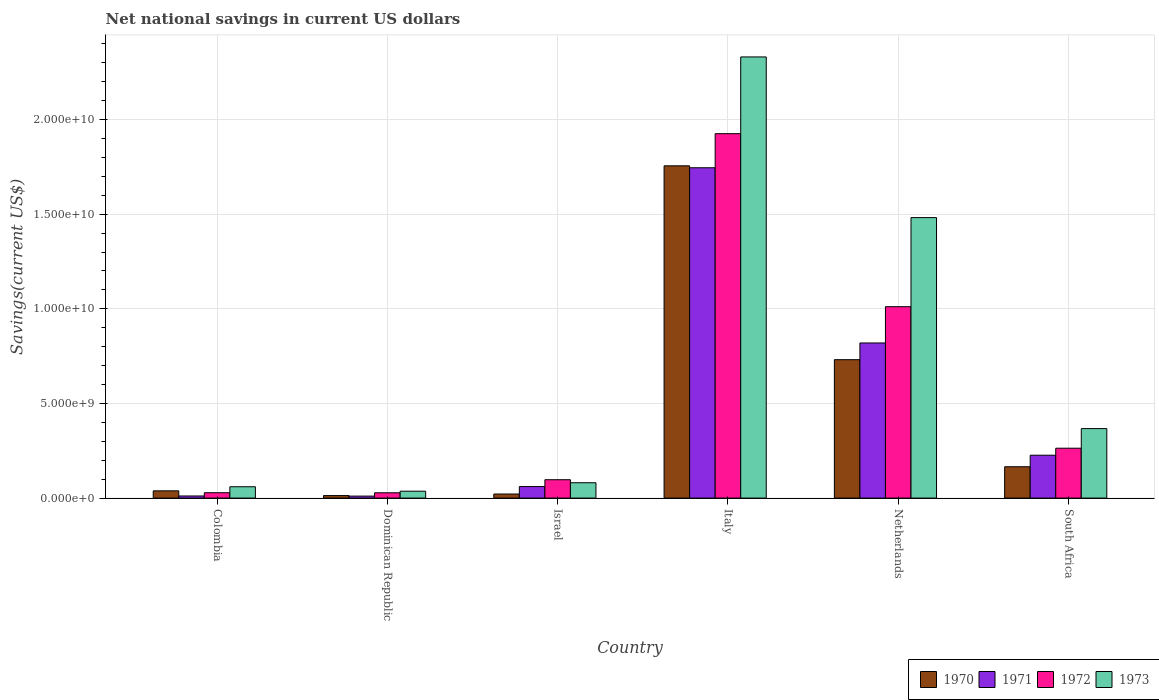How many different coloured bars are there?
Your answer should be very brief. 4. Are the number of bars per tick equal to the number of legend labels?
Your answer should be compact. Yes. How many bars are there on the 4th tick from the left?
Provide a succinct answer. 4. What is the net national savings in 1972 in Italy?
Give a very brief answer. 1.93e+1. Across all countries, what is the maximum net national savings in 1970?
Ensure brevity in your answer.  1.76e+1. Across all countries, what is the minimum net national savings in 1971?
Offer a terse response. 1.05e+08. In which country was the net national savings in 1971 minimum?
Offer a very short reply. Dominican Republic. What is the total net national savings in 1972 in the graph?
Ensure brevity in your answer.  3.35e+1. What is the difference between the net national savings in 1971 in Dominican Republic and that in Italy?
Offer a terse response. -1.73e+1. What is the difference between the net national savings in 1973 in South Africa and the net national savings in 1972 in Israel?
Offer a very short reply. 2.70e+09. What is the average net national savings in 1970 per country?
Offer a terse response. 4.54e+09. What is the difference between the net national savings of/in 1970 and net national savings of/in 1972 in Netherlands?
Your response must be concise. -2.80e+09. In how many countries, is the net national savings in 1972 greater than 10000000000 US$?
Keep it short and to the point. 2. What is the ratio of the net national savings in 1972 in Dominican Republic to that in Netherlands?
Offer a very short reply. 0.03. Is the net national savings in 1971 in Israel less than that in Italy?
Your response must be concise. Yes. Is the difference between the net national savings in 1970 in Colombia and Israel greater than the difference between the net national savings in 1972 in Colombia and Israel?
Provide a short and direct response. Yes. What is the difference between the highest and the second highest net national savings in 1970?
Offer a very short reply. 1.02e+1. What is the difference between the highest and the lowest net national savings in 1971?
Give a very brief answer. 1.73e+1. In how many countries, is the net national savings in 1972 greater than the average net national savings in 1972 taken over all countries?
Ensure brevity in your answer.  2. How many bars are there?
Ensure brevity in your answer.  24. What is the difference between two consecutive major ticks on the Y-axis?
Your response must be concise. 5.00e+09. Does the graph contain any zero values?
Your response must be concise. No. Does the graph contain grids?
Ensure brevity in your answer.  Yes. How many legend labels are there?
Offer a terse response. 4. What is the title of the graph?
Ensure brevity in your answer.  Net national savings in current US dollars. What is the label or title of the X-axis?
Your answer should be compact. Country. What is the label or title of the Y-axis?
Your answer should be very brief. Savings(current US$). What is the Savings(current US$) of 1970 in Colombia?
Offer a very short reply. 3.83e+08. What is the Savings(current US$) of 1971 in Colombia?
Provide a short and direct response. 1.11e+08. What is the Savings(current US$) of 1972 in Colombia?
Provide a short and direct response. 2.84e+08. What is the Savings(current US$) in 1973 in Colombia?
Keep it short and to the point. 5.98e+08. What is the Savings(current US$) in 1970 in Dominican Republic?
Your response must be concise. 1.33e+08. What is the Savings(current US$) of 1971 in Dominican Republic?
Give a very brief answer. 1.05e+08. What is the Savings(current US$) of 1972 in Dominican Republic?
Ensure brevity in your answer.  2.80e+08. What is the Savings(current US$) of 1973 in Dominican Republic?
Offer a very short reply. 3.65e+08. What is the Savings(current US$) in 1970 in Israel?
Provide a short and direct response. 2.15e+08. What is the Savings(current US$) in 1971 in Israel?
Provide a succinct answer. 6.09e+08. What is the Savings(current US$) of 1972 in Israel?
Your answer should be compact. 9.71e+08. What is the Savings(current US$) of 1973 in Israel?
Keep it short and to the point. 8.11e+08. What is the Savings(current US$) in 1970 in Italy?
Give a very brief answer. 1.76e+1. What is the Savings(current US$) in 1971 in Italy?
Your answer should be compact. 1.75e+1. What is the Savings(current US$) of 1972 in Italy?
Offer a terse response. 1.93e+1. What is the Savings(current US$) in 1973 in Italy?
Give a very brief answer. 2.33e+1. What is the Savings(current US$) in 1970 in Netherlands?
Your answer should be very brief. 7.31e+09. What is the Savings(current US$) in 1971 in Netherlands?
Give a very brief answer. 8.20e+09. What is the Savings(current US$) in 1972 in Netherlands?
Your response must be concise. 1.01e+1. What is the Savings(current US$) in 1973 in Netherlands?
Ensure brevity in your answer.  1.48e+1. What is the Savings(current US$) in 1970 in South Africa?
Your response must be concise. 1.66e+09. What is the Savings(current US$) of 1971 in South Africa?
Keep it short and to the point. 2.27e+09. What is the Savings(current US$) of 1972 in South Africa?
Provide a succinct answer. 2.64e+09. What is the Savings(current US$) of 1973 in South Africa?
Provide a short and direct response. 3.67e+09. Across all countries, what is the maximum Savings(current US$) of 1970?
Make the answer very short. 1.76e+1. Across all countries, what is the maximum Savings(current US$) of 1971?
Provide a short and direct response. 1.75e+1. Across all countries, what is the maximum Savings(current US$) of 1972?
Offer a very short reply. 1.93e+1. Across all countries, what is the maximum Savings(current US$) of 1973?
Keep it short and to the point. 2.33e+1. Across all countries, what is the minimum Savings(current US$) of 1970?
Offer a very short reply. 1.33e+08. Across all countries, what is the minimum Savings(current US$) of 1971?
Make the answer very short. 1.05e+08. Across all countries, what is the minimum Savings(current US$) in 1972?
Offer a very short reply. 2.80e+08. Across all countries, what is the minimum Savings(current US$) of 1973?
Your answer should be very brief. 3.65e+08. What is the total Savings(current US$) in 1970 in the graph?
Your answer should be very brief. 2.73e+1. What is the total Savings(current US$) in 1971 in the graph?
Your response must be concise. 2.87e+1. What is the total Savings(current US$) in 1972 in the graph?
Offer a very short reply. 3.35e+1. What is the total Savings(current US$) of 1973 in the graph?
Provide a succinct answer. 4.36e+1. What is the difference between the Savings(current US$) in 1970 in Colombia and that in Dominican Republic?
Offer a very short reply. 2.50e+08. What is the difference between the Savings(current US$) of 1971 in Colombia and that in Dominican Republic?
Keep it short and to the point. 6.03e+06. What is the difference between the Savings(current US$) of 1972 in Colombia and that in Dominican Republic?
Offer a very short reply. 3.48e+06. What is the difference between the Savings(current US$) in 1973 in Colombia and that in Dominican Republic?
Keep it short and to the point. 2.34e+08. What is the difference between the Savings(current US$) of 1970 in Colombia and that in Israel?
Provide a short and direct response. 1.68e+08. What is the difference between the Savings(current US$) in 1971 in Colombia and that in Israel?
Provide a short and direct response. -4.97e+08. What is the difference between the Savings(current US$) of 1972 in Colombia and that in Israel?
Offer a very short reply. -6.87e+08. What is the difference between the Savings(current US$) of 1973 in Colombia and that in Israel?
Offer a very short reply. -2.12e+08. What is the difference between the Savings(current US$) in 1970 in Colombia and that in Italy?
Offer a terse response. -1.72e+1. What is the difference between the Savings(current US$) in 1971 in Colombia and that in Italy?
Offer a very short reply. -1.73e+1. What is the difference between the Savings(current US$) of 1972 in Colombia and that in Italy?
Give a very brief answer. -1.90e+1. What is the difference between the Savings(current US$) in 1973 in Colombia and that in Italy?
Ensure brevity in your answer.  -2.27e+1. What is the difference between the Savings(current US$) of 1970 in Colombia and that in Netherlands?
Your answer should be compact. -6.93e+09. What is the difference between the Savings(current US$) in 1971 in Colombia and that in Netherlands?
Make the answer very short. -8.08e+09. What is the difference between the Savings(current US$) in 1972 in Colombia and that in Netherlands?
Offer a terse response. -9.83e+09. What is the difference between the Savings(current US$) of 1973 in Colombia and that in Netherlands?
Ensure brevity in your answer.  -1.42e+1. What is the difference between the Savings(current US$) in 1970 in Colombia and that in South Africa?
Give a very brief answer. -1.27e+09. What is the difference between the Savings(current US$) in 1971 in Colombia and that in South Africa?
Ensure brevity in your answer.  -2.15e+09. What is the difference between the Savings(current US$) in 1972 in Colombia and that in South Africa?
Give a very brief answer. -2.35e+09. What is the difference between the Savings(current US$) in 1973 in Colombia and that in South Africa?
Give a very brief answer. -3.07e+09. What is the difference between the Savings(current US$) in 1970 in Dominican Republic and that in Israel?
Ensure brevity in your answer.  -8.19e+07. What is the difference between the Savings(current US$) in 1971 in Dominican Republic and that in Israel?
Offer a very short reply. -5.03e+08. What is the difference between the Savings(current US$) in 1972 in Dominican Republic and that in Israel?
Your answer should be very brief. -6.90e+08. What is the difference between the Savings(current US$) in 1973 in Dominican Republic and that in Israel?
Provide a short and direct response. -4.46e+08. What is the difference between the Savings(current US$) of 1970 in Dominican Republic and that in Italy?
Provide a short and direct response. -1.74e+1. What is the difference between the Savings(current US$) of 1971 in Dominican Republic and that in Italy?
Provide a succinct answer. -1.73e+1. What is the difference between the Savings(current US$) in 1972 in Dominican Republic and that in Italy?
Provide a succinct answer. -1.90e+1. What is the difference between the Savings(current US$) of 1973 in Dominican Republic and that in Italy?
Offer a very short reply. -2.29e+1. What is the difference between the Savings(current US$) in 1970 in Dominican Republic and that in Netherlands?
Offer a very short reply. -7.18e+09. What is the difference between the Savings(current US$) of 1971 in Dominican Republic and that in Netherlands?
Your answer should be compact. -8.09e+09. What is the difference between the Savings(current US$) in 1972 in Dominican Republic and that in Netherlands?
Offer a terse response. -9.83e+09. What is the difference between the Savings(current US$) of 1973 in Dominican Republic and that in Netherlands?
Ensure brevity in your answer.  -1.45e+1. What is the difference between the Savings(current US$) of 1970 in Dominican Republic and that in South Africa?
Keep it short and to the point. -1.52e+09. What is the difference between the Savings(current US$) in 1971 in Dominican Republic and that in South Africa?
Ensure brevity in your answer.  -2.16e+09. What is the difference between the Savings(current US$) of 1972 in Dominican Republic and that in South Africa?
Make the answer very short. -2.35e+09. What is the difference between the Savings(current US$) of 1973 in Dominican Republic and that in South Africa?
Give a very brief answer. -3.31e+09. What is the difference between the Savings(current US$) of 1970 in Israel and that in Italy?
Your answer should be very brief. -1.73e+1. What is the difference between the Savings(current US$) of 1971 in Israel and that in Italy?
Keep it short and to the point. -1.68e+1. What is the difference between the Savings(current US$) of 1972 in Israel and that in Italy?
Keep it short and to the point. -1.83e+1. What is the difference between the Savings(current US$) of 1973 in Israel and that in Italy?
Your answer should be compact. -2.25e+1. What is the difference between the Savings(current US$) of 1970 in Israel and that in Netherlands?
Give a very brief answer. -7.10e+09. What is the difference between the Savings(current US$) in 1971 in Israel and that in Netherlands?
Ensure brevity in your answer.  -7.59e+09. What is the difference between the Savings(current US$) of 1972 in Israel and that in Netherlands?
Make the answer very short. -9.14e+09. What is the difference between the Savings(current US$) of 1973 in Israel and that in Netherlands?
Your response must be concise. -1.40e+1. What is the difference between the Savings(current US$) in 1970 in Israel and that in South Africa?
Your response must be concise. -1.44e+09. What is the difference between the Savings(current US$) in 1971 in Israel and that in South Africa?
Keep it short and to the point. -1.66e+09. What is the difference between the Savings(current US$) of 1972 in Israel and that in South Africa?
Keep it short and to the point. -1.66e+09. What is the difference between the Savings(current US$) of 1973 in Israel and that in South Africa?
Ensure brevity in your answer.  -2.86e+09. What is the difference between the Savings(current US$) of 1970 in Italy and that in Netherlands?
Offer a very short reply. 1.02e+1. What is the difference between the Savings(current US$) in 1971 in Italy and that in Netherlands?
Offer a very short reply. 9.26e+09. What is the difference between the Savings(current US$) in 1972 in Italy and that in Netherlands?
Offer a very short reply. 9.14e+09. What is the difference between the Savings(current US$) in 1973 in Italy and that in Netherlands?
Offer a very short reply. 8.49e+09. What is the difference between the Savings(current US$) of 1970 in Italy and that in South Africa?
Your answer should be compact. 1.59e+1. What is the difference between the Savings(current US$) in 1971 in Italy and that in South Africa?
Offer a very short reply. 1.52e+1. What is the difference between the Savings(current US$) of 1972 in Italy and that in South Africa?
Keep it short and to the point. 1.66e+1. What is the difference between the Savings(current US$) in 1973 in Italy and that in South Africa?
Ensure brevity in your answer.  1.96e+1. What is the difference between the Savings(current US$) of 1970 in Netherlands and that in South Africa?
Your answer should be very brief. 5.66e+09. What is the difference between the Savings(current US$) in 1971 in Netherlands and that in South Africa?
Offer a very short reply. 5.93e+09. What is the difference between the Savings(current US$) in 1972 in Netherlands and that in South Africa?
Your answer should be very brief. 7.48e+09. What is the difference between the Savings(current US$) of 1973 in Netherlands and that in South Africa?
Your answer should be compact. 1.11e+1. What is the difference between the Savings(current US$) of 1970 in Colombia and the Savings(current US$) of 1971 in Dominican Republic?
Your answer should be compact. 2.77e+08. What is the difference between the Savings(current US$) in 1970 in Colombia and the Savings(current US$) in 1972 in Dominican Republic?
Your answer should be very brief. 1.02e+08. What is the difference between the Savings(current US$) of 1970 in Colombia and the Savings(current US$) of 1973 in Dominican Republic?
Your answer should be very brief. 1.82e+07. What is the difference between the Savings(current US$) of 1971 in Colombia and the Savings(current US$) of 1972 in Dominican Republic?
Provide a succinct answer. -1.69e+08. What is the difference between the Savings(current US$) of 1971 in Colombia and the Savings(current US$) of 1973 in Dominican Republic?
Your answer should be very brief. -2.53e+08. What is the difference between the Savings(current US$) of 1972 in Colombia and the Savings(current US$) of 1973 in Dominican Republic?
Your answer should be very brief. -8.05e+07. What is the difference between the Savings(current US$) in 1970 in Colombia and the Savings(current US$) in 1971 in Israel?
Your response must be concise. -2.26e+08. What is the difference between the Savings(current US$) of 1970 in Colombia and the Savings(current US$) of 1972 in Israel?
Your response must be concise. -5.88e+08. What is the difference between the Savings(current US$) of 1970 in Colombia and the Savings(current US$) of 1973 in Israel?
Offer a very short reply. -4.28e+08. What is the difference between the Savings(current US$) of 1971 in Colombia and the Savings(current US$) of 1972 in Israel?
Ensure brevity in your answer.  -8.59e+08. What is the difference between the Savings(current US$) of 1971 in Colombia and the Savings(current US$) of 1973 in Israel?
Your answer should be compact. -6.99e+08. What is the difference between the Savings(current US$) in 1972 in Colombia and the Savings(current US$) in 1973 in Israel?
Provide a short and direct response. -5.27e+08. What is the difference between the Savings(current US$) of 1970 in Colombia and the Savings(current US$) of 1971 in Italy?
Your answer should be very brief. -1.71e+1. What is the difference between the Savings(current US$) of 1970 in Colombia and the Savings(current US$) of 1972 in Italy?
Offer a very short reply. -1.89e+1. What is the difference between the Savings(current US$) of 1970 in Colombia and the Savings(current US$) of 1973 in Italy?
Make the answer very short. -2.29e+1. What is the difference between the Savings(current US$) in 1971 in Colombia and the Savings(current US$) in 1972 in Italy?
Your answer should be compact. -1.91e+1. What is the difference between the Savings(current US$) in 1971 in Colombia and the Savings(current US$) in 1973 in Italy?
Your response must be concise. -2.32e+1. What is the difference between the Savings(current US$) of 1972 in Colombia and the Savings(current US$) of 1973 in Italy?
Make the answer very short. -2.30e+1. What is the difference between the Savings(current US$) of 1970 in Colombia and the Savings(current US$) of 1971 in Netherlands?
Offer a very short reply. -7.81e+09. What is the difference between the Savings(current US$) of 1970 in Colombia and the Savings(current US$) of 1972 in Netherlands?
Keep it short and to the point. -9.73e+09. What is the difference between the Savings(current US$) of 1970 in Colombia and the Savings(current US$) of 1973 in Netherlands?
Make the answer very short. -1.44e+1. What is the difference between the Savings(current US$) of 1971 in Colombia and the Savings(current US$) of 1972 in Netherlands?
Provide a succinct answer. -1.00e+1. What is the difference between the Savings(current US$) in 1971 in Colombia and the Savings(current US$) in 1973 in Netherlands?
Your answer should be very brief. -1.47e+1. What is the difference between the Savings(current US$) in 1972 in Colombia and the Savings(current US$) in 1973 in Netherlands?
Offer a terse response. -1.45e+1. What is the difference between the Savings(current US$) of 1970 in Colombia and the Savings(current US$) of 1971 in South Africa?
Provide a short and direct response. -1.88e+09. What is the difference between the Savings(current US$) in 1970 in Colombia and the Savings(current US$) in 1972 in South Africa?
Offer a terse response. -2.25e+09. What is the difference between the Savings(current US$) of 1970 in Colombia and the Savings(current US$) of 1973 in South Africa?
Ensure brevity in your answer.  -3.29e+09. What is the difference between the Savings(current US$) of 1971 in Colombia and the Savings(current US$) of 1972 in South Africa?
Provide a succinct answer. -2.52e+09. What is the difference between the Savings(current US$) in 1971 in Colombia and the Savings(current US$) in 1973 in South Africa?
Ensure brevity in your answer.  -3.56e+09. What is the difference between the Savings(current US$) in 1972 in Colombia and the Savings(current US$) in 1973 in South Africa?
Your answer should be compact. -3.39e+09. What is the difference between the Savings(current US$) of 1970 in Dominican Republic and the Savings(current US$) of 1971 in Israel?
Provide a short and direct response. -4.76e+08. What is the difference between the Savings(current US$) in 1970 in Dominican Republic and the Savings(current US$) in 1972 in Israel?
Your response must be concise. -8.38e+08. What is the difference between the Savings(current US$) in 1970 in Dominican Republic and the Savings(current US$) in 1973 in Israel?
Provide a succinct answer. -6.78e+08. What is the difference between the Savings(current US$) of 1971 in Dominican Republic and the Savings(current US$) of 1972 in Israel?
Your answer should be compact. -8.65e+08. What is the difference between the Savings(current US$) in 1971 in Dominican Republic and the Savings(current US$) in 1973 in Israel?
Your answer should be very brief. -7.05e+08. What is the difference between the Savings(current US$) in 1972 in Dominican Republic and the Savings(current US$) in 1973 in Israel?
Keep it short and to the point. -5.30e+08. What is the difference between the Savings(current US$) in 1970 in Dominican Republic and the Savings(current US$) in 1971 in Italy?
Make the answer very short. -1.73e+1. What is the difference between the Savings(current US$) of 1970 in Dominican Republic and the Savings(current US$) of 1972 in Italy?
Offer a very short reply. -1.91e+1. What is the difference between the Savings(current US$) in 1970 in Dominican Republic and the Savings(current US$) in 1973 in Italy?
Your answer should be compact. -2.32e+1. What is the difference between the Savings(current US$) of 1971 in Dominican Republic and the Savings(current US$) of 1972 in Italy?
Your answer should be very brief. -1.91e+1. What is the difference between the Savings(current US$) of 1971 in Dominican Republic and the Savings(current US$) of 1973 in Italy?
Provide a succinct answer. -2.32e+1. What is the difference between the Savings(current US$) of 1972 in Dominican Republic and the Savings(current US$) of 1973 in Italy?
Keep it short and to the point. -2.30e+1. What is the difference between the Savings(current US$) of 1970 in Dominican Republic and the Savings(current US$) of 1971 in Netherlands?
Your answer should be compact. -8.06e+09. What is the difference between the Savings(current US$) in 1970 in Dominican Republic and the Savings(current US$) in 1972 in Netherlands?
Offer a very short reply. -9.98e+09. What is the difference between the Savings(current US$) in 1970 in Dominican Republic and the Savings(current US$) in 1973 in Netherlands?
Keep it short and to the point. -1.47e+1. What is the difference between the Savings(current US$) in 1971 in Dominican Republic and the Savings(current US$) in 1972 in Netherlands?
Ensure brevity in your answer.  -1.00e+1. What is the difference between the Savings(current US$) of 1971 in Dominican Republic and the Savings(current US$) of 1973 in Netherlands?
Your response must be concise. -1.47e+1. What is the difference between the Savings(current US$) of 1972 in Dominican Republic and the Savings(current US$) of 1973 in Netherlands?
Your response must be concise. -1.45e+1. What is the difference between the Savings(current US$) in 1970 in Dominican Republic and the Savings(current US$) in 1971 in South Africa?
Your answer should be very brief. -2.13e+09. What is the difference between the Savings(current US$) of 1970 in Dominican Republic and the Savings(current US$) of 1972 in South Africa?
Offer a very short reply. -2.50e+09. What is the difference between the Savings(current US$) of 1970 in Dominican Republic and the Savings(current US$) of 1973 in South Africa?
Provide a short and direct response. -3.54e+09. What is the difference between the Savings(current US$) in 1971 in Dominican Republic and the Savings(current US$) in 1972 in South Africa?
Your answer should be compact. -2.53e+09. What is the difference between the Savings(current US$) of 1971 in Dominican Republic and the Savings(current US$) of 1973 in South Africa?
Make the answer very short. -3.57e+09. What is the difference between the Savings(current US$) of 1972 in Dominican Republic and the Savings(current US$) of 1973 in South Africa?
Give a very brief answer. -3.39e+09. What is the difference between the Savings(current US$) in 1970 in Israel and the Savings(current US$) in 1971 in Italy?
Provide a succinct answer. -1.72e+1. What is the difference between the Savings(current US$) of 1970 in Israel and the Savings(current US$) of 1972 in Italy?
Your answer should be very brief. -1.90e+1. What is the difference between the Savings(current US$) of 1970 in Israel and the Savings(current US$) of 1973 in Italy?
Provide a short and direct response. -2.31e+1. What is the difference between the Savings(current US$) in 1971 in Israel and the Savings(current US$) in 1972 in Italy?
Keep it short and to the point. -1.86e+1. What is the difference between the Savings(current US$) of 1971 in Israel and the Savings(current US$) of 1973 in Italy?
Your answer should be compact. -2.27e+1. What is the difference between the Savings(current US$) in 1972 in Israel and the Savings(current US$) in 1973 in Italy?
Your response must be concise. -2.23e+1. What is the difference between the Savings(current US$) of 1970 in Israel and the Savings(current US$) of 1971 in Netherlands?
Ensure brevity in your answer.  -7.98e+09. What is the difference between the Savings(current US$) in 1970 in Israel and the Savings(current US$) in 1972 in Netherlands?
Keep it short and to the point. -9.90e+09. What is the difference between the Savings(current US$) in 1970 in Israel and the Savings(current US$) in 1973 in Netherlands?
Your response must be concise. -1.46e+1. What is the difference between the Savings(current US$) of 1971 in Israel and the Savings(current US$) of 1972 in Netherlands?
Your response must be concise. -9.50e+09. What is the difference between the Savings(current US$) of 1971 in Israel and the Savings(current US$) of 1973 in Netherlands?
Provide a succinct answer. -1.42e+1. What is the difference between the Savings(current US$) in 1972 in Israel and the Savings(current US$) in 1973 in Netherlands?
Offer a terse response. -1.38e+1. What is the difference between the Savings(current US$) of 1970 in Israel and the Savings(current US$) of 1971 in South Africa?
Provide a succinct answer. -2.05e+09. What is the difference between the Savings(current US$) of 1970 in Israel and the Savings(current US$) of 1972 in South Africa?
Give a very brief answer. -2.42e+09. What is the difference between the Savings(current US$) in 1970 in Israel and the Savings(current US$) in 1973 in South Africa?
Your response must be concise. -3.46e+09. What is the difference between the Savings(current US$) of 1971 in Israel and the Savings(current US$) of 1972 in South Africa?
Give a very brief answer. -2.03e+09. What is the difference between the Savings(current US$) in 1971 in Israel and the Savings(current US$) in 1973 in South Africa?
Offer a terse response. -3.06e+09. What is the difference between the Savings(current US$) of 1972 in Israel and the Savings(current US$) of 1973 in South Africa?
Offer a very short reply. -2.70e+09. What is the difference between the Savings(current US$) in 1970 in Italy and the Savings(current US$) in 1971 in Netherlands?
Offer a terse response. 9.36e+09. What is the difference between the Savings(current US$) of 1970 in Italy and the Savings(current US$) of 1972 in Netherlands?
Your response must be concise. 7.44e+09. What is the difference between the Savings(current US$) of 1970 in Italy and the Savings(current US$) of 1973 in Netherlands?
Keep it short and to the point. 2.74e+09. What is the difference between the Savings(current US$) in 1971 in Italy and the Savings(current US$) in 1972 in Netherlands?
Your answer should be compact. 7.34e+09. What is the difference between the Savings(current US$) of 1971 in Italy and the Savings(current US$) of 1973 in Netherlands?
Make the answer very short. 2.63e+09. What is the difference between the Savings(current US$) in 1972 in Italy and the Savings(current US$) in 1973 in Netherlands?
Offer a very short reply. 4.44e+09. What is the difference between the Savings(current US$) of 1970 in Italy and the Savings(current US$) of 1971 in South Africa?
Keep it short and to the point. 1.53e+1. What is the difference between the Savings(current US$) in 1970 in Italy and the Savings(current US$) in 1972 in South Africa?
Provide a succinct answer. 1.49e+1. What is the difference between the Savings(current US$) in 1970 in Italy and the Savings(current US$) in 1973 in South Africa?
Your response must be concise. 1.39e+1. What is the difference between the Savings(current US$) in 1971 in Italy and the Savings(current US$) in 1972 in South Africa?
Ensure brevity in your answer.  1.48e+1. What is the difference between the Savings(current US$) of 1971 in Italy and the Savings(current US$) of 1973 in South Africa?
Your answer should be very brief. 1.38e+1. What is the difference between the Savings(current US$) in 1972 in Italy and the Savings(current US$) in 1973 in South Africa?
Your response must be concise. 1.56e+1. What is the difference between the Savings(current US$) of 1970 in Netherlands and the Savings(current US$) of 1971 in South Africa?
Provide a succinct answer. 5.05e+09. What is the difference between the Savings(current US$) in 1970 in Netherlands and the Savings(current US$) in 1972 in South Africa?
Give a very brief answer. 4.68e+09. What is the difference between the Savings(current US$) of 1970 in Netherlands and the Savings(current US$) of 1973 in South Africa?
Give a very brief answer. 3.64e+09. What is the difference between the Savings(current US$) in 1971 in Netherlands and the Savings(current US$) in 1972 in South Africa?
Give a very brief answer. 5.56e+09. What is the difference between the Savings(current US$) in 1971 in Netherlands and the Savings(current US$) in 1973 in South Africa?
Provide a succinct answer. 4.52e+09. What is the difference between the Savings(current US$) in 1972 in Netherlands and the Savings(current US$) in 1973 in South Africa?
Provide a short and direct response. 6.44e+09. What is the average Savings(current US$) in 1970 per country?
Make the answer very short. 4.54e+09. What is the average Savings(current US$) in 1971 per country?
Your answer should be compact. 4.79e+09. What is the average Savings(current US$) of 1972 per country?
Your response must be concise. 5.59e+09. What is the average Savings(current US$) of 1973 per country?
Give a very brief answer. 7.26e+09. What is the difference between the Savings(current US$) in 1970 and Savings(current US$) in 1971 in Colombia?
Give a very brief answer. 2.71e+08. What is the difference between the Savings(current US$) of 1970 and Savings(current US$) of 1972 in Colombia?
Make the answer very short. 9.87e+07. What is the difference between the Savings(current US$) of 1970 and Savings(current US$) of 1973 in Colombia?
Offer a terse response. -2.16e+08. What is the difference between the Savings(current US$) of 1971 and Savings(current US$) of 1972 in Colombia?
Your answer should be compact. -1.73e+08. What is the difference between the Savings(current US$) in 1971 and Savings(current US$) in 1973 in Colombia?
Provide a short and direct response. -4.87e+08. What is the difference between the Savings(current US$) of 1972 and Savings(current US$) of 1973 in Colombia?
Provide a short and direct response. -3.14e+08. What is the difference between the Savings(current US$) of 1970 and Savings(current US$) of 1971 in Dominican Republic?
Your answer should be very brief. 2.74e+07. What is the difference between the Savings(current US$) of 1970 and Savings(current US$) of 1972 in Dominican Republic?
Offer a very short reply. -1.48e+08. What is the difference between the Savings(current US$) in 1970 and Savings(current US$) in 1973 in Dominican Republic?
Make the answer very short. -2.32e+08. What is the difference between the Savings(current US$) in 1971 and Savings(current US$) in 1972 in Dominican Republic?
Make the answer very short. -1.75e+08. What is the difference between the Savings(current US$) of 1971 and Savings(current US$) of 1973 in Dominican Republic?
Offer a very short reply. -2.59e+08. What is the difference between the Savings(current US$) in 1972 and Savings(current US$) in 1973 in Dominican Republic?
Provide a short and direct response. -8.40e+07. What is the difference between the Savings(current US$) in 1970 and Savings(current US$) in 1971 in Israel?
Offer a very short reply. -3.94e+08. What is the difference between the Savings(current US$) of 1970 and Savings(current US$) of 1972 in Israel?
Provide a short and direct response. -7.56e+08. What is the difference between the Savings(current US$) in 1970 and Savings(current US$) in 1973 in Israel?
Provide a short and direct response. -5.96e+08. What is the difference between the Savings(current US$) in 1971 and Savings(current US$) in 1972 in Israel?
Your response must be concise. -3.62e+08. What is the difference between the Savings(current US$) of 1971 and Savings(current US$) of 1973 in Israel?
Offer a terse response. -2.02e+08. What is the difference between the Savings(current US$) of 1972 and Savings(current US$) of 1973 in Israel?
Offer a terse response. 1.60e+08. What is the difference between the Savings(current US$) of 1970 and Savings(current US$) of 1971 in Italy?
Your answer should be very brief. 1.03e+08. What is the difference between the Savings(current US$) of 1970 and Savings(current US$) of 1972 in Italy?
Provide a succinct answer. -1.70e+09. What is the difference between the Savings(current US$) of 1970 and Savings(current US$) of 1973 in Italy?
Give a very brief answer. -5.75e+09. What is the difference between the Savings(current US$) in 1971 and Savings(current US$) in 1972 in Italy?
Ensure brevity in your answer.  -1.80e+09. What is the difference between the Savings(current US$) of 1971 and Savings(current US$) of 1973 in Italy?
Offer a terse response. -5.86e+09. What is the difference between the Savings(current US$) of 1972 and Savings(current US$) of 1973 in Italy?
Provide a short and direct response. -4.05e+09. What is the difference between the Savings(current US$) in 1970 and Savings(current US$) in 1971 in Netherlands?
Make the answer very short. -8.83e+08. What is the difference between the Savings(current US$) in 1970 and Savings(current US$) in 1972 in Netherlands?
Make the answer very short. -2.80e+09. What is the difference between the Savings(current US$) in 1970 and Savings(current US$) in 1973 in Netherlands?
Your answer should be very brief. -7.51e+09. What is the difference between the Savings(current US$) in 1971 and Savings(current US$) in 1972 in Netherlands?
Provide a succinct answer. -1.92e+09. What is the difference between the Savings(current US$) in 1971 and Savings(current US$) in 1973 in Netherlands?
Offer a very short reply. -6.62e+09. What is the difference between the Savings(current US$) of 1972 and Savings(current US$) of 1973 in Netherlands?
Give a very brief answer. -4.71e+09. What is the difference between the Savings(current US$) of 1970 and Savings(current US$) of 1971 in South Africa?
Provide a short and direct response. -6.09e+08. What is the difference between the Savings(current US$) of 1970 and Savings(current US$) of 1972 in South Africa?
Your response must be concise. -9.79e+08. What is the difference between the Savings(current US$) in 1970 and Savings(current US$) in 1973 in South Africa?
Ensure brevity in your answer.  -2.02e+09. What is the difference between the Savings(current US$) in 1971 and Savings(current US$) in 1972 in South Africa?
Your response must be concise. -3.70e+08. What is the difference between the Savings(current US$) of 1971 and Savings(current US$) of 1973 in South Africa?
Provide a short and direct response. -1.41e+09. What is the difference between the Savings(current US$) in 1972 and Savings(current US$) in 1973 in South Africa?
Provide a succinct answer. -1.04e+09. What is the ratio of the Savings(current US$) in 1970 in Colombia to that in Dominican Republic?
Your response must be concise. 2.88. What is the ratio of the Savings(current US$) in 1971 in Colombia to that in Dominican Republic?
Make the answer very short. 1.06. What is the ratio of the Savings(current US$) of 1972 in Colombia to that in Dominican Republic?
Give a very brief answer. 1.01. What is the ratio of the Savings(current US$) in 1973 in Colombia to that in Dominican Republic?
Provide a succinct answer. 1.64. What is the ratio of the Savings(current US$) of 1970 in Colombia to that in Israel?
Make the answer very short. 1.78. What is the ratio of the Savings(current US$) of 1971 in Colombia to that in Israel?
Your response must be concise. 0.18. What is the ratio of the Savings(current US$) of 1972 in Colombia to that in Israel?
Ensure brevity in your answer.  0.29. What is the ratio of the Savings(current US$) in 1973 in Colombia to that in Israel?
Your response must be concise. 0.74. What is the ratio of the Savings(current US$) in 1970 in Colombia to that in Italy?
Ensure brevity in your answer.  0.02. What is the ratio of the Savings(current US$) in 1971 in Colombia to that in Italy?
Provide a succinct answer. 0.01. What is the ratio of the Savings(current US$) in 1972 in Colombia to that in Italy?
Offer a very short reply. 0.01. What is the ratio of the Savings(current US$) in 1973 in Colombia to that in Italy?
Ensure brevity in your answer.  0.03. What is the ratio of the Savings(current US$) of 1970 in Colombia to that in Netherlands?
Make the answer very short. 0.05. What is the ratio of the Savings(current US$) in 1971 in Colombia to that in Netherlands?
Offer a terse response. 0.01. What is the ratio of the Savings(current US$) of 1972 in Colombia to that in Netherlands?
Your answer should be very brief. 0.03. What is the ratio of the Savings(current US$) of 1973 in Colombia to that in Netherlands?
Provide a succinct answer. 0.04. What is the ratio of the Savings(current US$) in 1970 in Colombia to that in South Africa?
Make the answer very short. 0.23. What is the ratio of the Savings(current US$) of 1971 in Colombia to that in South Africa?
Give a very brief answer. 0.05. What is the ratio of the Savings(current US$) of 1972 in Colombia to that in South Africa?
Keep it short and to the point. 0.11. What is the ratio of the Savings(current US$) in 1973 in Colombia to that in South Africa?
Your answer should be compact. 0.16. What is the ratio of the Savings(current US$) in 1970 in Dominican Republic to that in Israel?
Your answer should be very brief. 0.62. What is the ratio of the Savings(current US$) in 1971 in Dominican Republic to that in Israel?
Your response must be concise. 0.17. What is the ratio of the Savings(current US$) in 1972 in Dominican Republic to that in Israel?
Make the answer very short. 0.29. What is the ratio of the Savings(current US$) in 1973 in Dominican Republic to that in Israel?
Keep it short and to the point. 0.45. What is the ratio of the Savings(current US$) in 1970 in Dominican Republic to that in Italy?
Your response must be concise. 0.01. What is the ratio of the Savings(current US$) of 1971 in Dominican Republic to that in Italy?
Provide a short and direct response. 0.01. What is the ratio of the Savings(current US$) of 1972 in Dominican Republic to that in Italy?
Give a very brief answer. 0.01. What is the ratio of the Savings(current US$) of 1973 in Dominican Republic to that in Italy?
Ensure brevity in your answer.  0.02. What is the ratio of the Savings(current US$) of 1970 in Dominican Republic to that in Netherlands?
Ensure brevity in your answer.  0.02. What is the ratio of the Savings(current US$) of 1971 in Dominican Republic to that in Netherlands?
Ensure brevity in your answer.  0.01. What is the ratio of the Savings(current US$) in 1972 in Dominican Republic to that in Netherlands?
Make the answer very short. 0.03. What is the ratio of the Savings(current US$) in 1973 in Dominican Republic to that in Netherlands?
Your response must be concise. 0.02. What is the ratio of the Savings(current US$) of 1970 in Dominican Republic to that in South Africa?
Your answer should be very brief. 0.08. What is the ratio of the Savings(current US$) of 1971 in Dominican Republic to that in South Africa?
Offer a very short reply. 0.05. What is the ratio of the Savings(current US$) in 1972 in Dominican Republic to that in South Africa?
Your answer should be very brief. 0.11. What is the ratio of the Savings(current US$) in 1973 in Dominican Republic to that in South Africa?
Your answer should be very brief. 0.1. What is the ratio of the Savings(current US$) of 1970 in Israel to that in Italy?
Offer a terse response. 0.01. What is the ratio of the Savings(current US$) in 1971 in Israel to that in Italy?
Your answer should be compact. 0.03. What is the ratio of the Savings(current US$) of 1972 in Israel to that in Italy?
Offer a very short reply. 0.05. What is the ratio of the Savings(current US$) of 1973 in Israel to that in Italy?
Give a very brief answer. 0.03. What is the ratio of the Savings(current US$) of 1970 in Israel to that in Netherlands?
Give a very brief answer. 0.03. What is the ratio of the Savings(current US$) in 1971 in Israel to that in Netherlands?
Offer a terse response. 0.07. What is the ratio of the Savings(current US$) of 1972 in Israel to that in Netherlands?
Offer a terse response. 0.1. What is the ratio of the Savings(current US$) in 1973 in Israel to that in Netherlands?
Make the answer very short. 0.05. What is the ratio of the Savings(current US$) in 1970 in Israel to that in South Africa?
Give a very brief answer. 0.13. What is the ratio of the Savings(current US$) in 1971 in Israel to that in South Africa?
Keep it short and to the point. 0.27. What is the ratio of the Savings(current US$) of 1972 in Israel to that in South Africa?
Keep it short and to the point. 0.37. What is the ratio of the Savings(current US$) in 1973 in Israel to that in South Africa?
Keep it short and to the point. 0.22. What is the ratio of the Savings(current US$) in 1970 in Italy to that in Netherlands?
Provide a short and direct response. 2.4. What is the ratio of the Savings(current US$) in 1971 in Italy to that in Netherlands?
Your response must be concise. 2.13. What is the ratio of the Savings(current US$) of 1972 in Italy to that in Netherlands?
Offer a very short reply. 1.9. What is the ratio of the Savings(current US$) of 1973 in Italy to that in Netherlands?
Your response must be concise. 1.57. What is the ratio of the Savings(current US$) of 1970 in Italy to that in South Africa?
Keep it short and to the point. 10.6. What is the ratio of the Savings(current US$) in 1971 in Italy to that in South Africa?
Give a very brief answer. 7.7. What is the ratio of the Savings(current US$) in 1972 in Italy to that in South Africa?
Offer a very short reply. 7.31. What is the ratio of the Savings(current US$) of 1973 in Italy to that in South Africa?
Give a very brief answer. 6.35. What is the ratio of the Savings(current US$) in 1970 in Netherlands to that in South Africa?
Give a very brief answer. 4.42. What is the ratio of the Savings(current US$) of 1971 in Netherlands to that in South Africa?
Keep it short and to the point. 3.62. What is the ratio of the Savings(current US$) in 1972 in Netherlands to that in South Africa?
Provide a short and direct response. 3.84. What is the ratio of the Savings(current US$) in 1973 in Netherlands to that in South Africa?
Offer a terse response. 4.04. What is the difference between the highest and the second highest Savings(current US$) in 1970?
Provide a succinct answer. 1.02e+1. What is the difference between the highest and the second highest Savings(current US$) in 1971?
Your answer should be very brief. 9.26e+09. What is the difference between the highest and the second highest Savings(current US$) in 1972?
Keep it short and to the point. 9.14e+09. What is the difference between the highest and the second highest Savings(current US$) in 1973?
Offer a very short reply. 8.49e+09. What is the difference between the highest and the lowest Savings(current US$) in 1970?
Offer a terse response. 1.74e+1. What is the difference between the highest and the lowest Savings(current US$) in 1971?
Your answer should be compact. 1.73e+1. What is the difference between the highest and the lowest Savings(current US$) in 1972?
Your answer should be compact. 1.90e+1. What is the difference between the highest and the lowest Savings(current US$) in 1973?
Provide a succinct answer. 2.29e+1. 